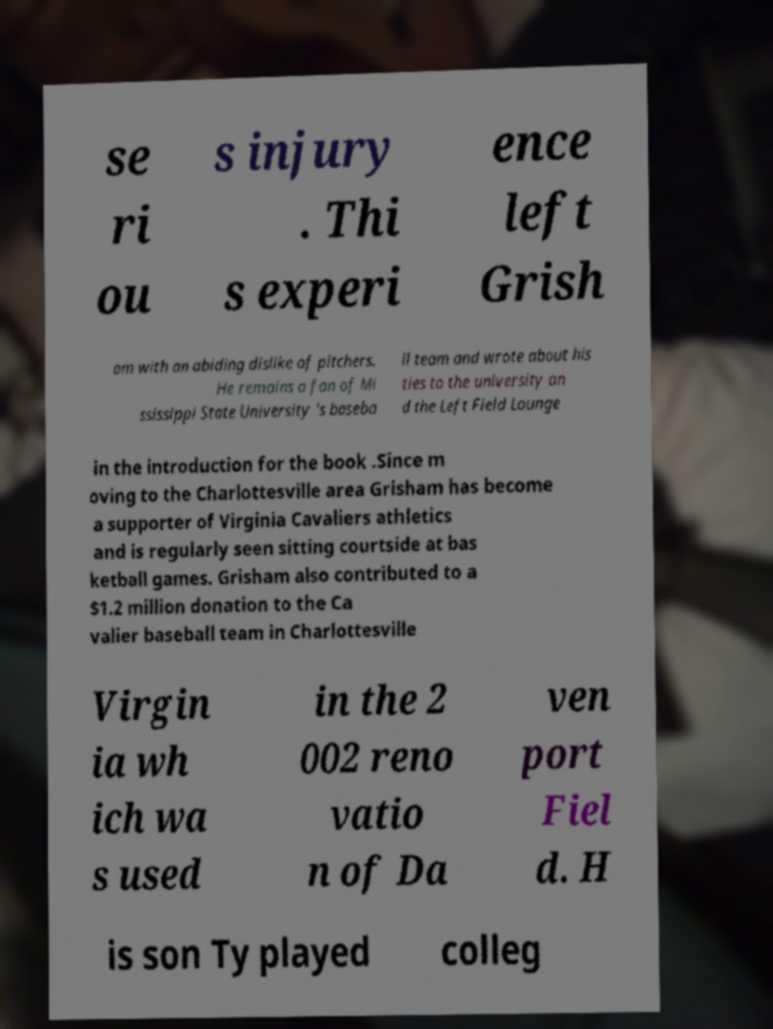For documentation purposes, I need the text within this image transcribed. Could you provide that? se ri ou s injury . Thi s experi ence left Grish am with an abiding dislike of pitchers. He remains a fan of Mi ssissippi State University 's baseba ll team and wrote about his ties to the university an d the Left Field Lounge in the introduction for the book .Since m oving to the Charlottesville area Grisham has become a supporter of Virginia Cavaliers athletics and is regularly seen sitting courtside at bas ketball games. Grisham also contributed to a $1.2 million donation to the Ca valier baseball team in Charlottesville Virgin ia wh ich wa s used in the 2 002 reno vatio n of Da ven port Fiel d. H is son Ty played colleg 